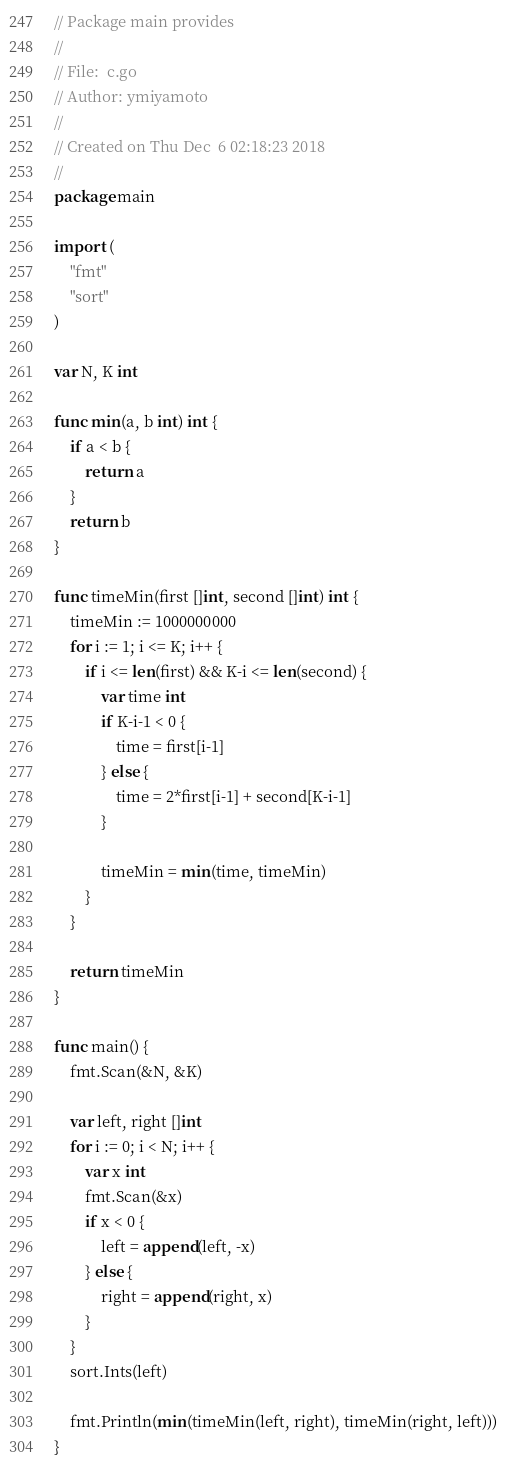Convert code to text. <code><loc_0><loc_0><loc_500><loc_500><_Go_>// Package main provides
//
// File:  c.go
// Author: ymiyamoto
//
// Created on Thu Dec  6 02:18:23 2018
//
package main

import (
	"fmt"
	"sort"
)

var N, K int

func min(a, b int) int {
	if a < b {
		return a
	}
	return b
}

func timeMin(first []int, second []int) int {
	timeMin := 1000000000
	for i := 1; i <= K; i++ {
		if i <= len(first) && K-i <= len(second) {
			var time int
			if K-i-1 < 0 {
				time = first[i-1]
			} else {
				time = 2*first[i-1] + second[K-i-1]
			}

			timeMin = min(time, timeMin)
		}
	}

	return timeMin
}

func main() {
	fmt.Scan(&N, &K)

	var left, right []int
	for i := 0; i < N; i++ {
		var x int
		fmt.Scan(&x)
		if x < 0 {
			left = append(left, -x)
		} else {
			right = append(right, x)
		}
	}
	sort.Ints(left)

	fmt.Println(min(timeMin(left, right), timeMin(right, left)))
}
</code> 